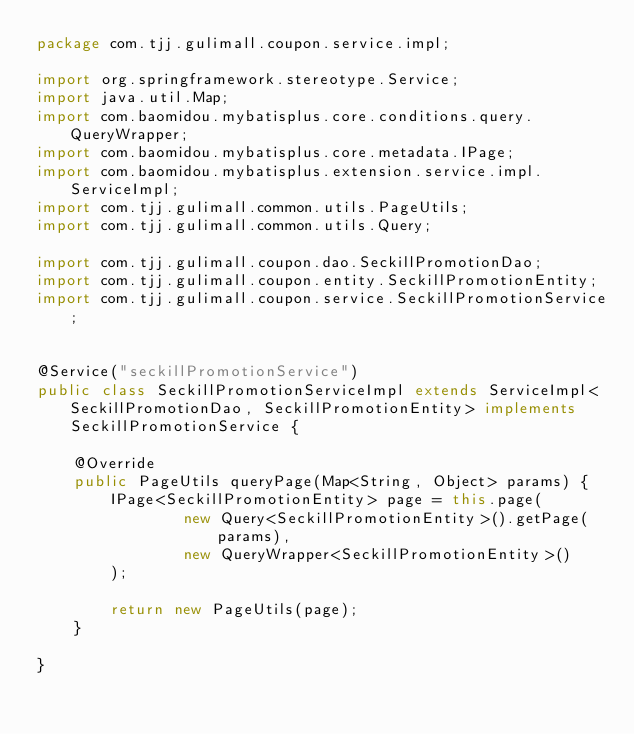<code> <loc_0><loc_0><loc_500><loc_500><_Java_>package com.tjj.gulimall.coupon.service.impl;

import org.springframework.stereotype.Service;
import java.util.Map;
import com.baomidou.mybatisplus.core.conditions.query.QueryWrapper;
import com.baomidou.mybatisplus.core.metadata.IPage;
import com.baomidou.mybatisplus.extension.service.impl.ServiceImpl;
import com.tjj.gulimall.common.utils.PageUtils;
import com.tjj.gulimall.common.utils.Query;

import com.tjj.gulimall.coupon.dao.SeckillPromotionDao;
import com.tjj.gulimall.coupon.entity.SeckillPromotionEntity;
import com.tjj.gulimall.coupon.service.SeckillPromotionService;


@Service("seckillPromotionService")
public class SeckillPromotionServiceImpl extends ServiceImpl<SeckillPromotionDao, SeckillPromotionEntity> implements SeckillPromotionService {

    @Override
    public PageUtils queryPage(Map<String, Object> params) {
        IPage<SeckillPromotionEntity> page = this.page(
                new Query<SeckillPromotionEntity>().getPage(params),
                new QueryWrapper<SeckillPromotionEntity>()
        );

        return new PageUtils(page);
    }

}</code> 